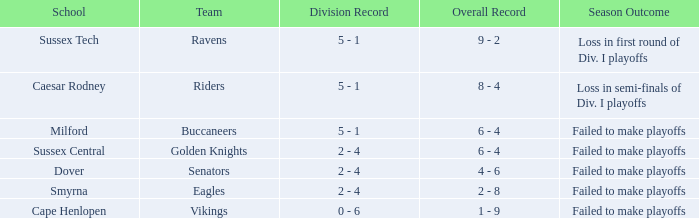Parse the table in full. {'header': ['School', 'Team', 'Division Record', 'Overall Record', 'Season Outcome'], 'rows': [['Sussex Tech', 'Ravens', '5 - 1', '9 - 2', 'Loss in first round of Div. I playoffs'], ['Caesar Rodney', 'Riders', '5 - 1', '8 - 4', 'Loss in semi-finals of Div. I playoffs'], ['Milford', 'Buccaneers', '5 - 1', '6 - 4', 'Failed to make playoffs'], ['Sussex Central', 'Golden Knights', '2 - 4', '6 - 4', 'Failed to make playoffs'], ['Dover', 'Senators', '2 - 4', '4 - 6', 'Failed to make playoffs'], ['Smyrna', 'Eagles', '2 - 4', '2 - 8', 'Failed to make playoffs'], ['Cape Henlopen', 'Vikings', '0 - 6', '1 - 9', 'Failed to make playoffs']]} What is the Overall Record for the School in Milford? 6 - 4. 